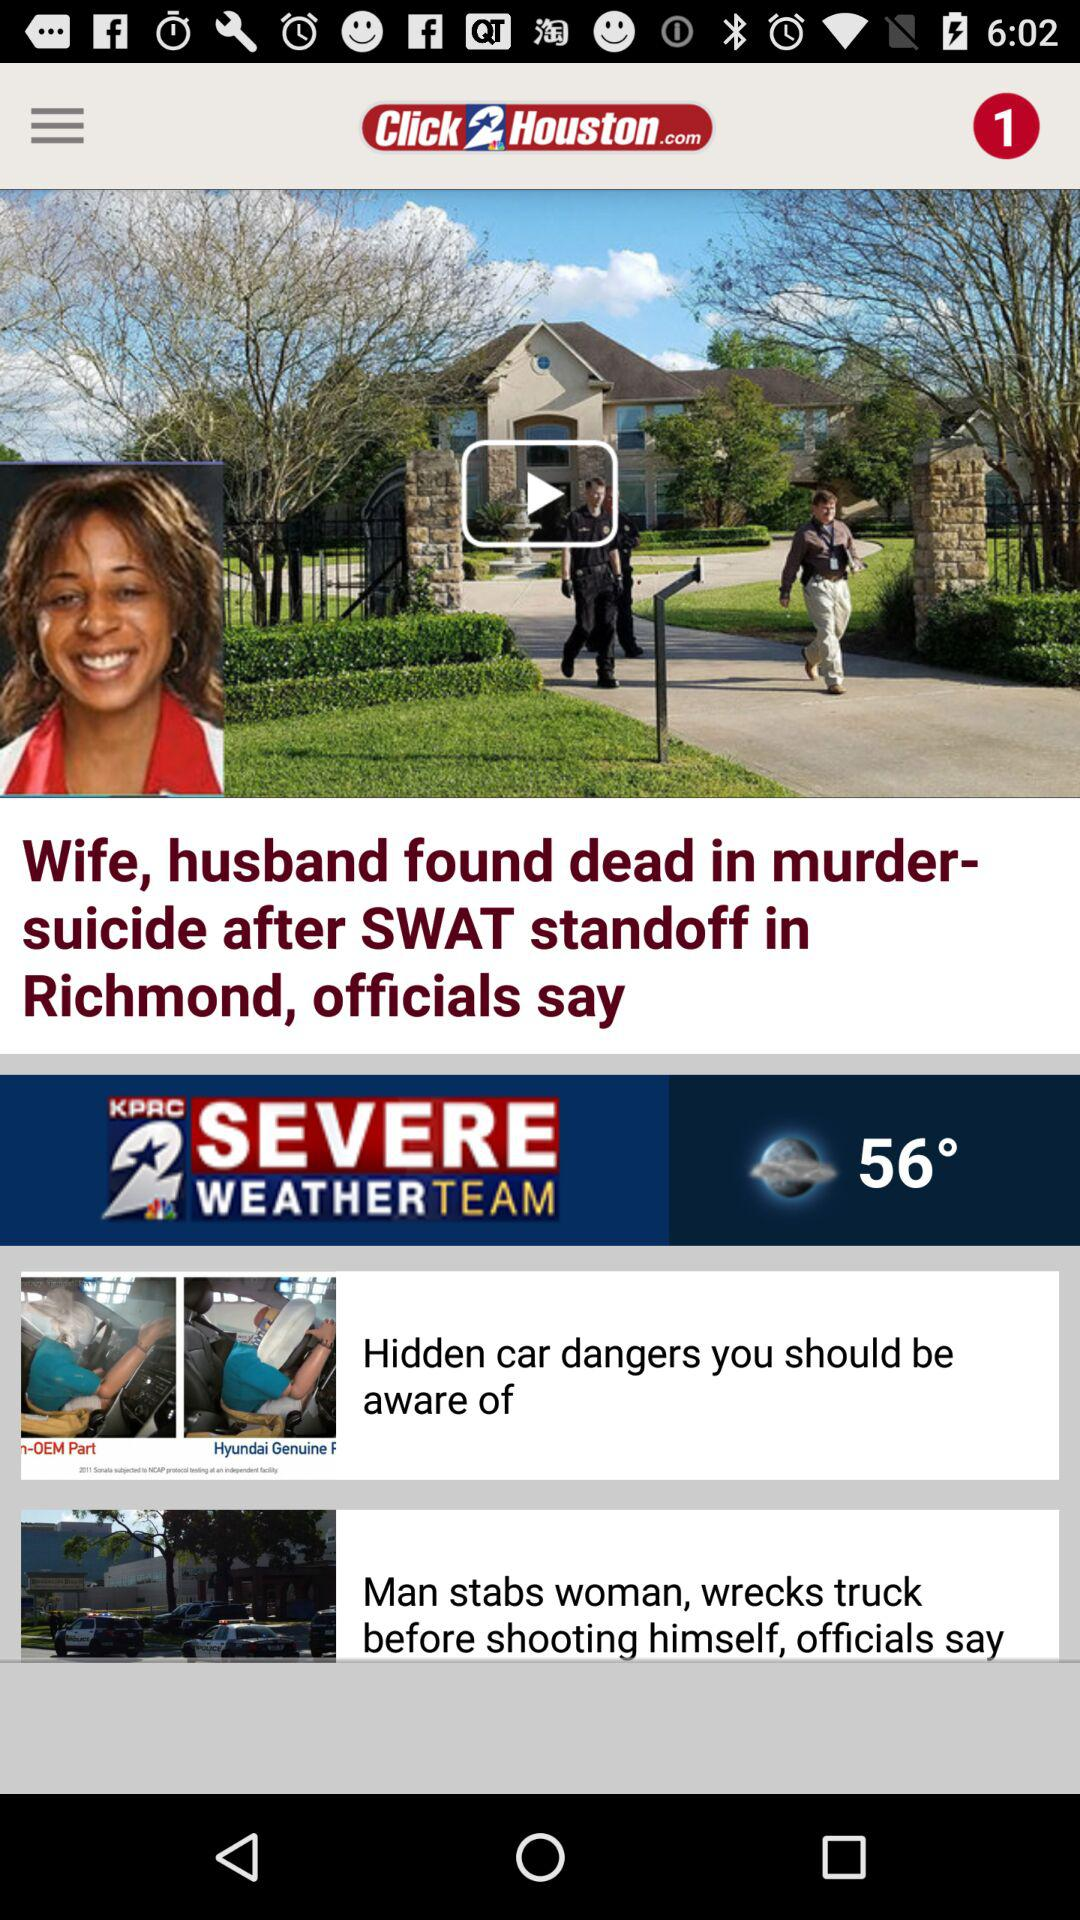What is the headline of the news? The headline is "Wife, husband found dead in murder-suicide after SWAT standoff in Richmond, officials say". 